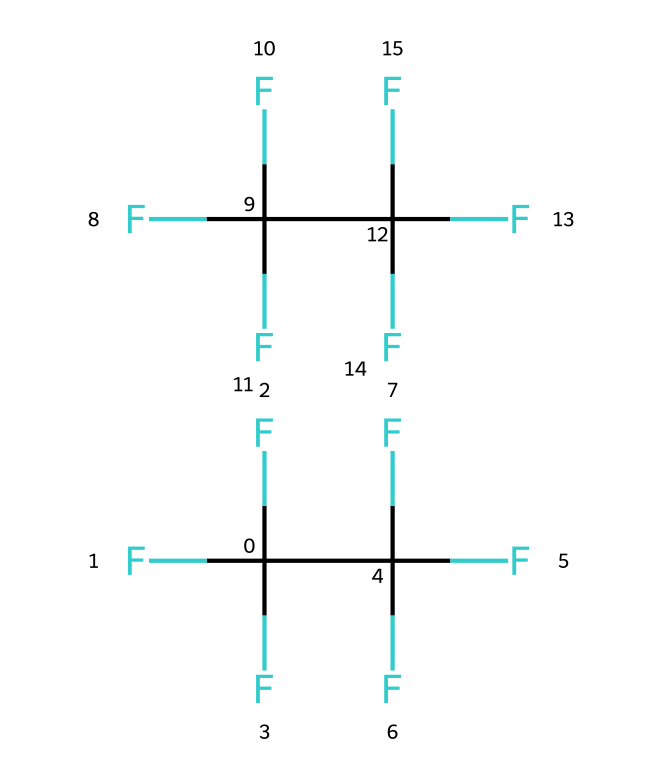What is the total number of carbon atoms in R-410A? In the SMILES representation of R-410A, there are two groups that include carbon atoms, each group contains one carbon atom shown as "C". Therefore, the total is 2 carbon atoms.
Answer: 2 How many fluorine atoms are present in R-410A? Counting the "F" symbols in the SMILES representation reveals there are 8 fluorine atoms total, with each "F" representing one fluorine atom.
Answer: 8 What is the molecular formula of R-410A? By analyzing the carbon and fluorine counts, the molecular formula can be deduced as C2F8, based on 2 carbon atoms and 8 fluorine atoms.
Answer: C2F8 What type of chemical bond is primarily present in R-410A? The presence of the fluorine atoms suggests strong covalent bonds between the carbon and fluorine atoms. Covalent bonds hold the atoms together in this molecular structure.
Answer: covalent Does R-410A have any hydrogen atoms in its structure? Upon examining the chemical structure in the SMILES notation, there are no hydrogen atoms present, which is typical for highly fluorinated refrigerants.
Answer: no What makes R-410A environmentally preferable compared to some older refrigerants? R-410A has zero ozone depletion potential and a lower global warming potential than some older refrigerants, making it more environmentally friendly.
Answer: environmentally friendly 